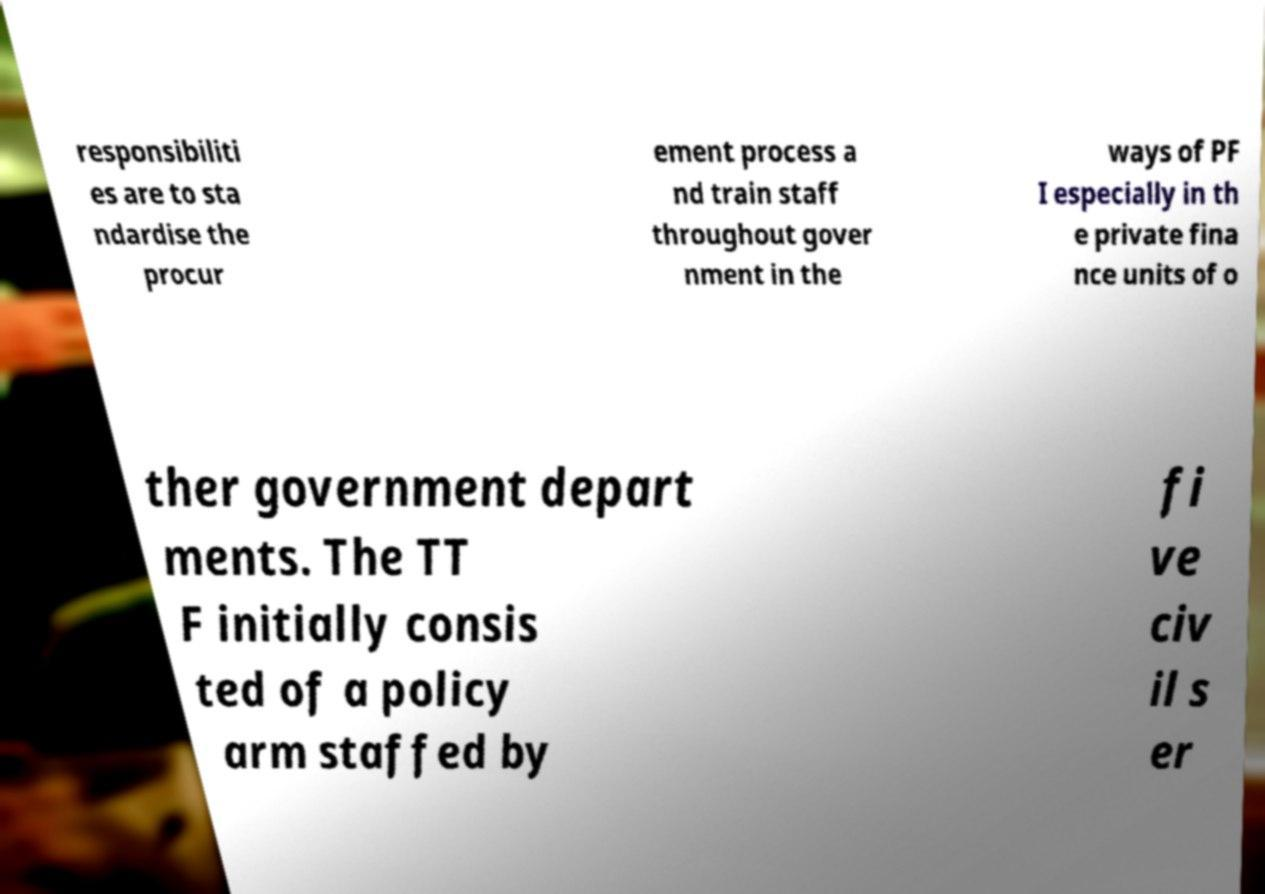Can you read and provide the text displayed in the image?This photo seems to have some interesting text. Can you extract and type it out for me? responsibiliti es are to sta ndardise the procur ement process a nd train staff throughout gover nment in the ways of PF I especially in th e private fina nce units of o ther government depart ments. The TT F initially consis ted of a policy arm staffed by fi ve civ il s er 